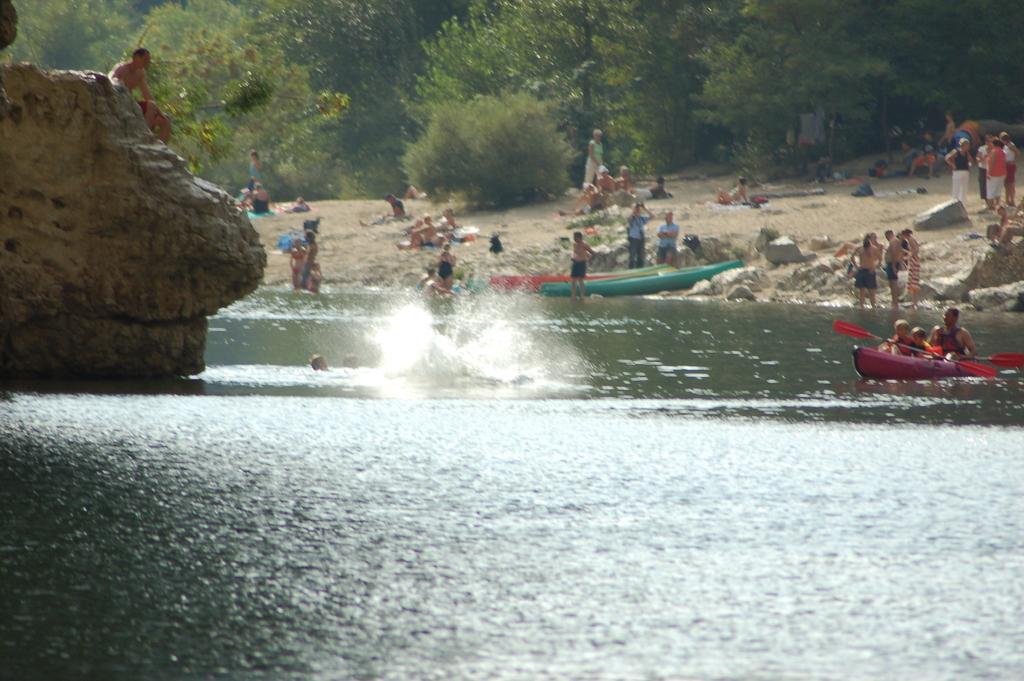How would you summarize this image in a sentence or two? In the image we can see there is a lake and there are people swimming in the lake. There are few people sitting on the boat and holding paddles in their hands. There are other people sitting on the rock and behind there are people sitting on the ground. There are lot of trees at the back. 